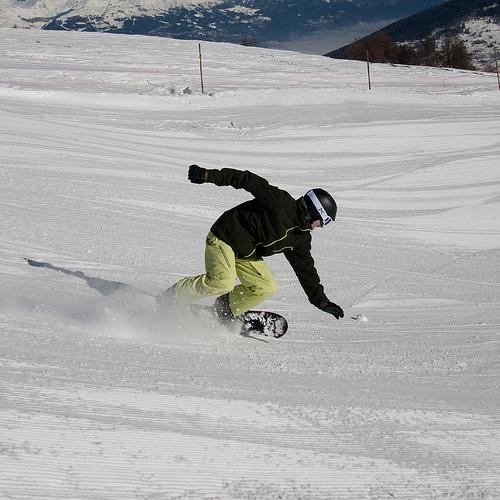Describe any small details or objects in the image not directly related to the man or his snowboarding activities. There are wooden poles in the snow, a small pile of snow, and a small ball of white snow in the image. Discuss the man's snowboarding equipment in the image, including colors and any specific details. The man is snowboarding on a black snowboard covered in snow, with snow flying up around it. He is wearing a black helmet with a white band, white snow goggles, and black gloves. Identify the main activity taking place in the image, along with the clothing and gear worn by the person involved. The main activity is a person snowboarding down a snowy slope, wearing a black helmet, black ski jacket, yellow ski pants, and riding a black snowboard. Imagine you are advertising a snowboarding product featured in the image. What product would you choose and how would you describe it? Introducing our premium black snowboard with superior grip and control on the slopes! Designed for snowboarding enthusiasts, this board's outstanding performance allows you to effortlessly glide through the snow while enjoying maximum stability, even when snow is flying up around it. Describe the type of pants the man is wearing in the image, including color and any unique features. The man is wearing yellow ski pants with zippers on the legs, providing easy access to pockets or ventilation during snowboarding activities. What is the appearance of the man in the image, and what is he wearing on his head? The man has a black helmet on his head with a gray stripe and white snow goggles. What is the main source of movement in the image, and what is causing this movement? The main source of movement is the snowboarder sliding down the snow-covered slope, causing powdered snow to fly up under his snowboard. Examine the image and identify any shadows or areas of darkness. There is a gray shadow cast on the snow, possibly from the man snowboarding or from the nearby trees on the snowy mountain. Explain the terrain in the image and mention any noteworthy landscape features. The terrain is a snow-covered ski slope with grooved and packed down snow, a ridge on top of a snowy mountain, more mountains on the horizon, and bare brown trees in the skyline. Pick one item from the man's outfit and describe it in detail, focusing on its color and any visible features. The man is wearing a black ski jacket with a white stripe and a gray zipper. The jacket appears to be warm and suitable for snowboarding. 